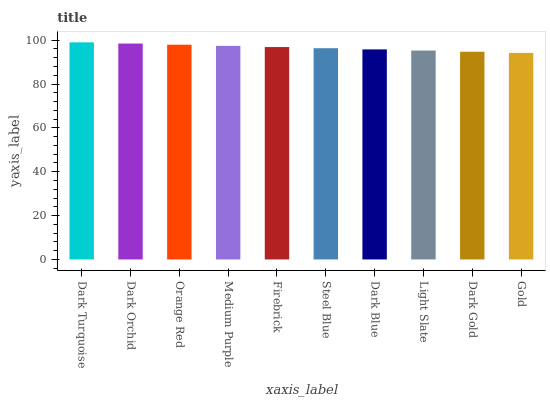Is Gold the minimum?
Answer yes or no. Yes. Is Dark Turquoise the maximum?
Answer yes or no. Yes. Is Dark Orchid the minimum?
Answer yes or no. No. Is Dark Orchid the maximum?
Answer yes or no. No. Is Dark Turquoise greater than Dark Orchid?
Answer yes or no. Yes. Is Dark Orchid less than Dark Turquoise?
Answer yes or no. Yes. Is Dark Orchid greater than Dark Turquoise?
Answer yes or no. No. Is Dark Turquoise less than Dark Orchid?
Answer yes or no. No. Is Firebrick the high median?
Answer yes or no. Yes. Is Steel Blue the low median?
Answer yes or no. Yes. Is Medium Purple the high median?
Answer yes or no. No. Is Dark Turquoise the low median?
Answer yes or no. No. 